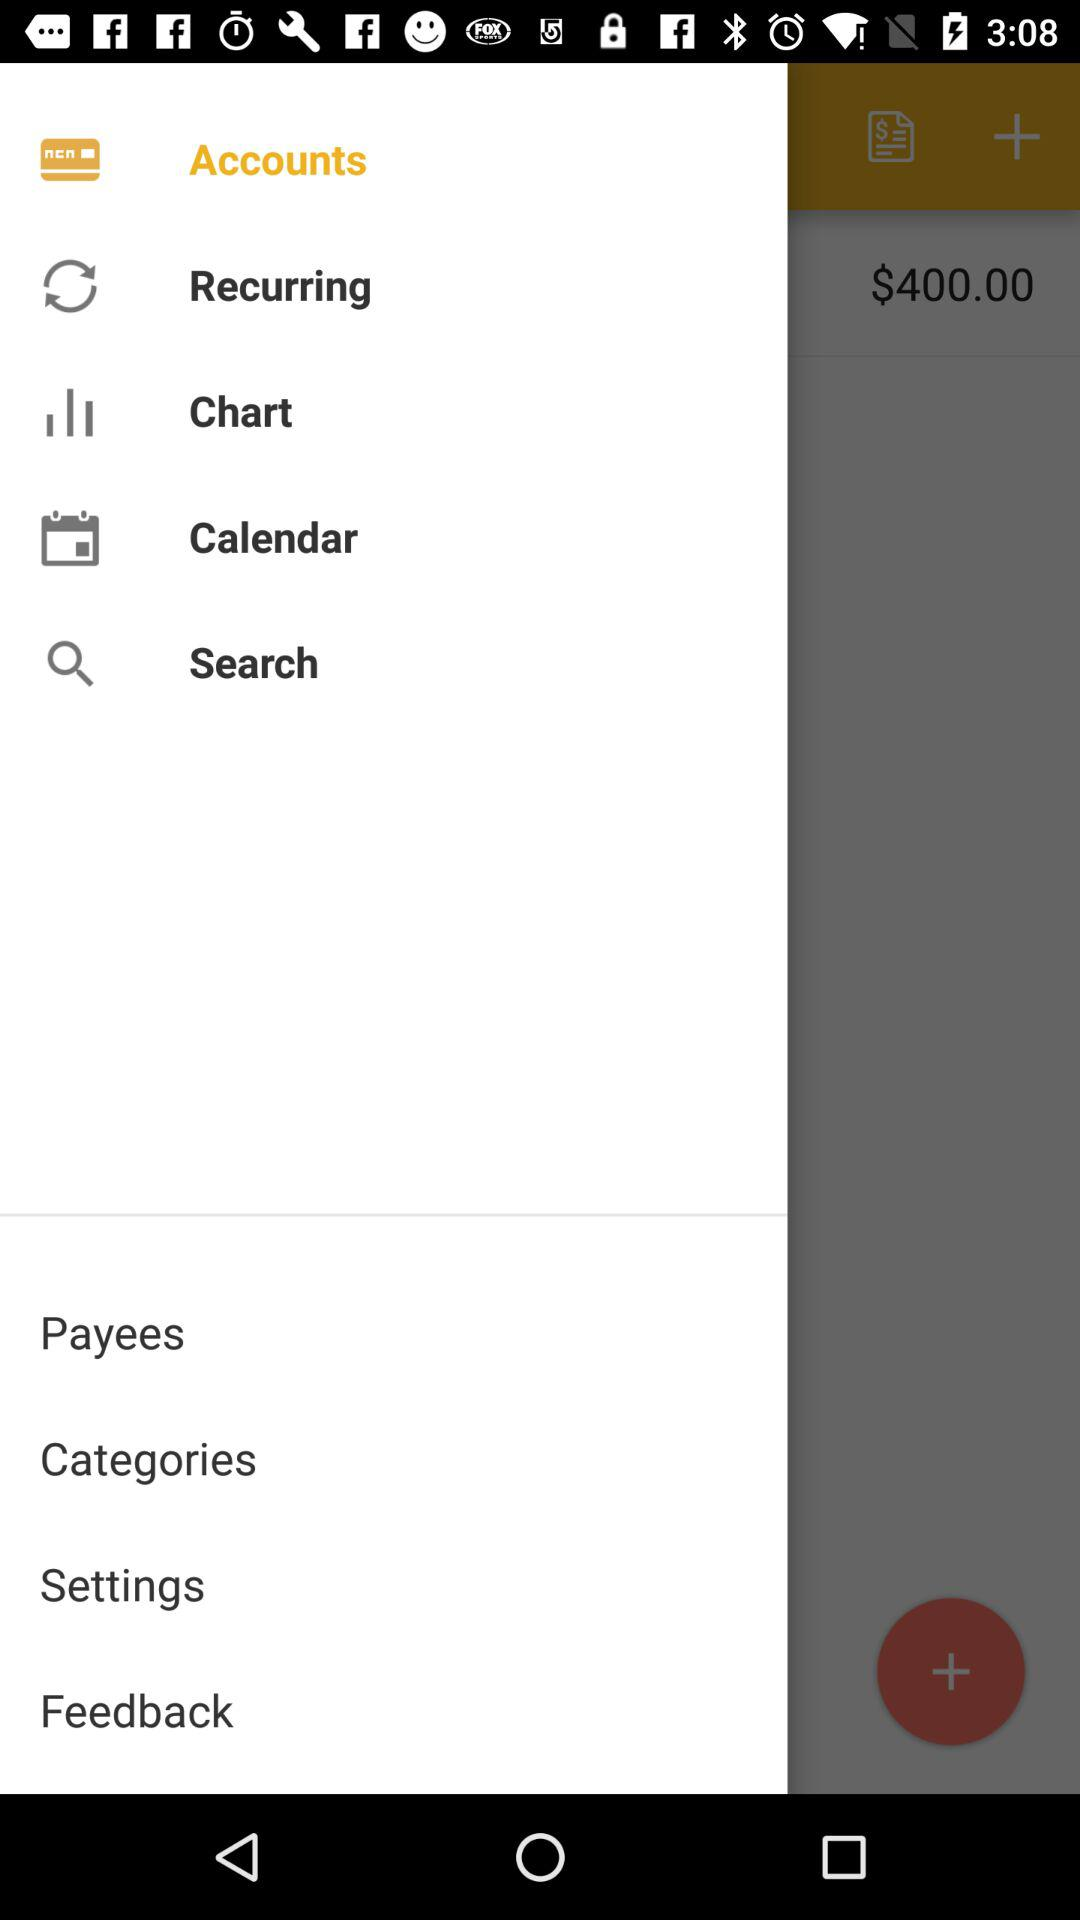How much money is in my account?
Answer the question using a single word or phrase. $400.00 